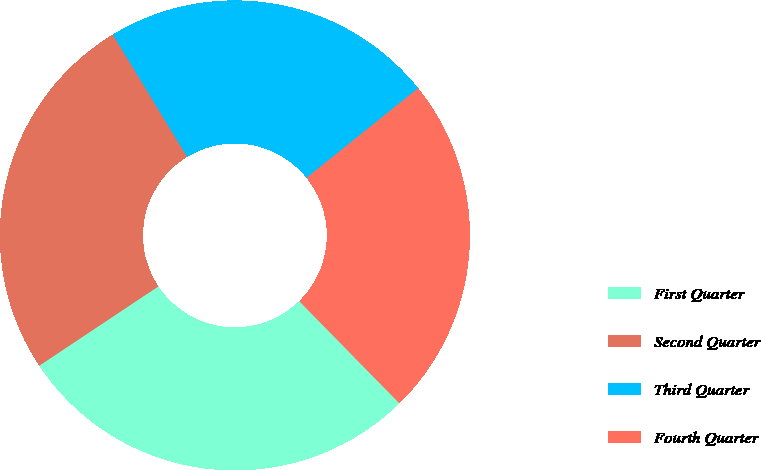Convert chart to OTSL. <chart><loc_0><loc_0><loc_500><loc_500><pie_chart><fcel>First Quarter<fcel>Second Quarter<fcel>Third Quarter<fcel>Fourth Quarter<nl><fcel>27.99%<fcel>25.66%<fcel>22.92%<fcel>23.43%<nl></chart> 